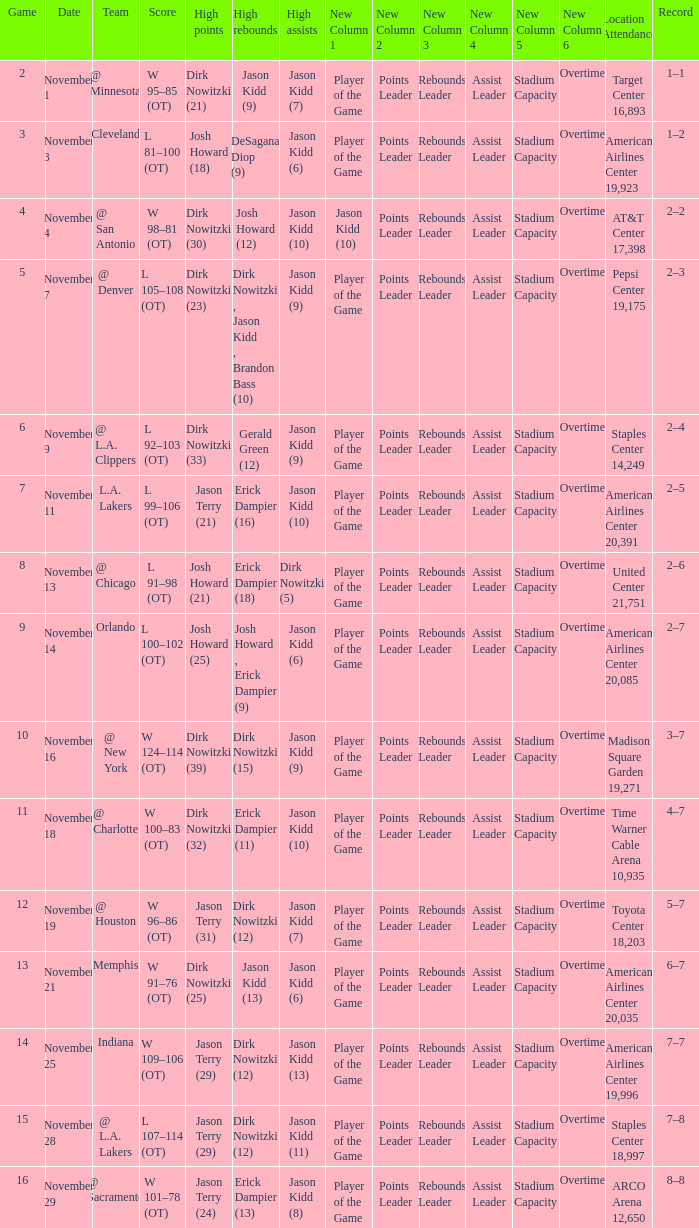What is the lowest Game, when Date is "November 1"? 2.0. 